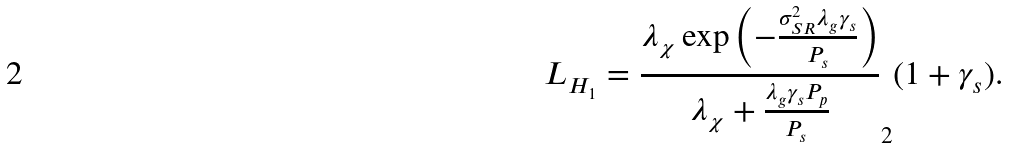<formula> <loc_0><loc_0><loc_500><loc_500>L _ { H _ { 1 } } = \frac { \lambda _ { \chi } \exp \left ( - \frac { \sigma _ { S R } ^ { 2 } \lambda _ { g } \gamma _ { s } } { P _ { s } } \right ) } { \lambda _ { \chi } + \frac { \lambda _ { g } \gamma _ { s } P _ { p } } { P _ { s } } } _ { 2 } ( 1 + \gamma _ { s } ) .</formula> 